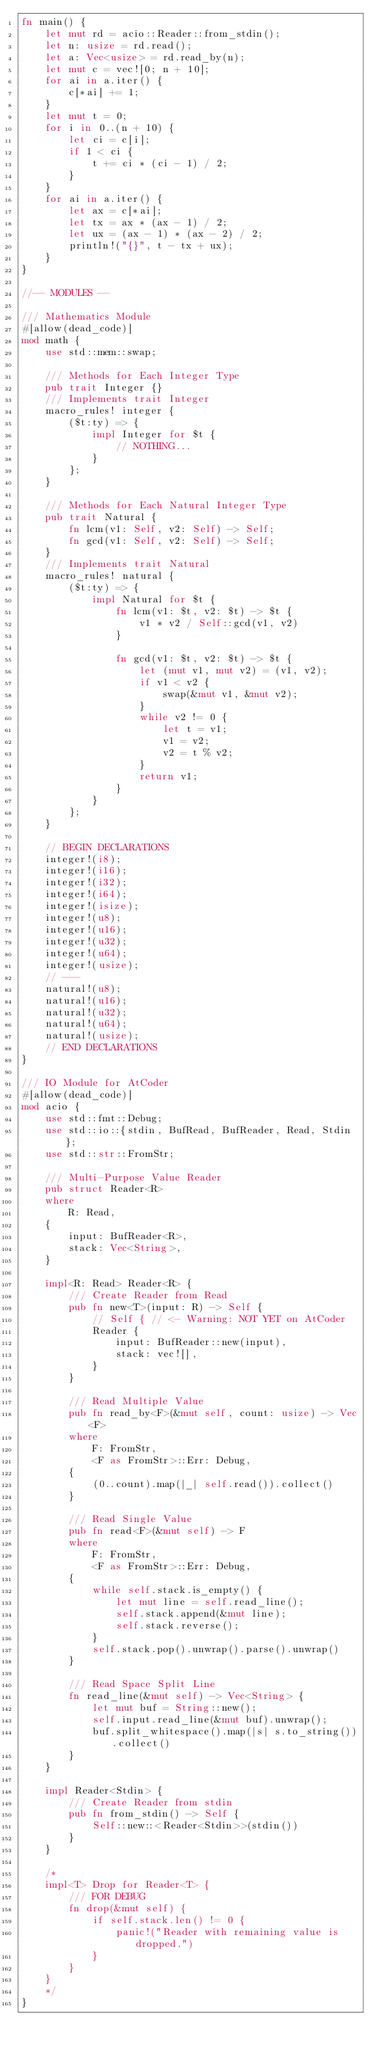Convert code to text. <code><loc_0><loc_0><loc_500><loc_500><_Rust_>fn main() {
    let mut rd = acio::Reader::from_stdin();
    let n: usize = rd.read();
    let a: Vec<usize> = rd.read_by(n);
    let mut c = vec![0; n + 10];
    for ai in a.iter() {
        c[*ai] += 1;
    }
    let mut t = 0;
    for i in 0..(n + 10) {
        let ci = c[i];
        if 1 < ci {
            t += ci * (ci - 1) / 2;
        }
    }
    for ai in a.iter() {
        let ax = c[*ai];
        let tx = ax * (ax - 1) / 2;
        let ux = (ax - 1) * (ax - 2) / 2;
        println!("{}", t - tx + ux);
    }
}

//-- MODULES --

/// Mathematics Module
#[allow(dead_code)]
mod math {
    use std::mem::swap;

    /// Methods for Each Integer Type
    pub trait Integer {}
    /// Implements trait Integer
    macro_rules! integer {
        ($t:ty) => {
            impl Integer for $t {
                // NOTHING...
            }
        };
    }

    /// Methods for Each Natural Integer Type
    pub trait Natural {
        fn lcm(v1: Self, v2: Self) -> Self;
        fn gcd(v1: Self, v2: Self) -> Self;
    }
    /// Implements trait Natural
    macro_rules! natural {
        ($t:ty) => {
            impl Natural for $t {
                fn lcm(v1: $t, v2: $t) -> $t {
                    v1 * v2 / Self::gcd(v1, v2)
                }

                fn gcd(v1: $t, v2: $t) -> $t {
                    let (mut v1, mut v2) = (v1, v2);
                    if v1 < v2 {
                        swap(&mut v1, &mut v2);
                    }
                    while v2 != 0 {
                        let t = v1;
                        v1 = v2;
                        v2 = t % v2;
                    }
                    return v1;
                }
            }
        };
    }

    // BEGIN DECLARATIONS
    integer!(i8);
    integer!(i16);
    integer!(i32);
    integer!(i64);
    integer!(isize);
    integer!(u8);
    integer!(u16);
    integer!(u32);
    integer!(u64);
    integer!(usize);
    // ---
    natural!(u8);
    natural!(u16);
    natural!(u32);
    natural!(u64);
    natural!(usize);
    // END DECLARATIONS
}

/// IO Module for AtCoder
#[allow(dead_code)]
mod acio {
    use std::fmt::Debug;
    use std::io::{stdin, BufRead, BufReader, Read, Stdin};
    use std::str::FromStr;

    /// Multi-Purpose Value Reader
    pub struct Reader<R>
    where
        R: Read,
    {
        input: BufReader<R>,
        stack: Vec<String>,
    }

    impl<R: Read> Reader<R> {
        /// Create Reader from Read
        pub fn new<T>(input: R) -> Self {
            // Self { // <- Warning: NOT YET on AtCoder
            Reader {
                input: BufReader::new(input),
                stack: vec![],
            }
        }

        /// Read Multiple Value
        pub fn read_by<F>(&mut self, count: usize) -> Vec<F>
        where
            F: FromStr,
            <F as FromStr>::Err: Debug,
        {
            (0..count).map(|_| self.read()).collect()
        }

        /// Read Single Value
        pub fn read<F>(&mut self) -> F
        where
            F: FromStr,
            <F as FromStr>::Err: Debug,
        {
            while self.stack.is_empty() {
                let mut line = self.read_line();
                self.stack.append(&mut line);
                self.stack.reverse();
            }
            self.stack.pop().unwrap().parse().unwrap()
        }

        /// Read Space Split Line
        fn read_line(&mut self) -> Vec<String> {
            let mut buf = String::new();
            self.input.read_line(&mut buf).unwrap();
            buf.split_whitespace().map(|s| s.to_string()).collect()
        }
    }

    impl Reader<Stdin> {
        /// Create Reader from stdin
        pub fn from_stdin() -> Self {
            Self::new::<Reader<Stdin>>(stdin())
        }
    }

    /*
    impl<T> Drop for Reader<T> {
        /// FOR DEBUG
        fn drop(&mut self) {
            if self.stack.len() != 0 {
                panic!("Reader with remaining value is dropped.")
            }
        }
    }
    */
}
</code> 